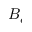Convert formula to latex. <formula><loc_0><loc_0><loc_500><loc_500>B _ { e }</formula> 